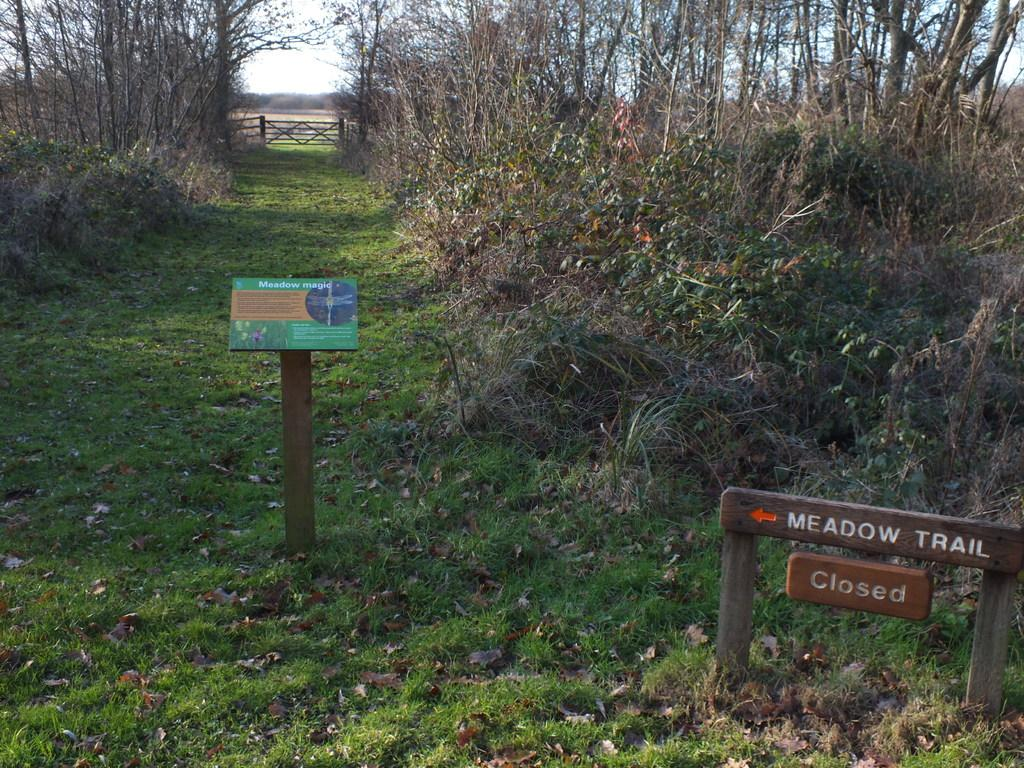What is placed on the grass in the image? There are boards on the grass in the image. What can be seen in the background of the image? There are trees visible in the image. What type of vegetation is present on the grass in the image? Dry leaves are present on the grass in the image. How many rabbits can be seen hopping on the vein in the image? There are no rabbits or veins present in the image. What type of support is provided by the trees in the image? The trees in the image do not provide any visible support; they are part of the background. 